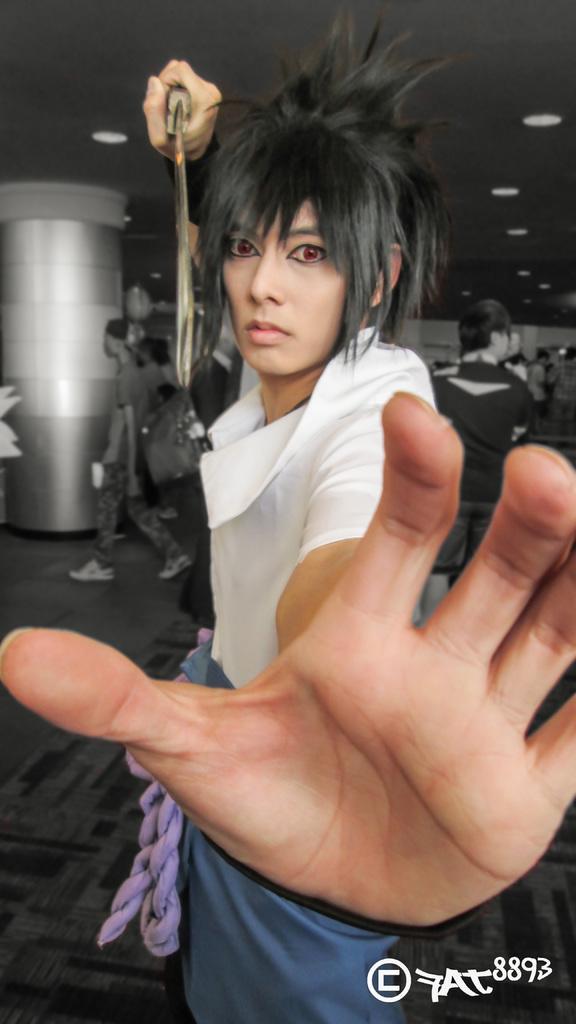In one or two sentences, can you explain what this image depicts? In this edited image there is a woman standing. She is holding a knife in her hand. The background is black and white in color. There are few people walking. To the left there is a pillar. There are lights to the ceiling. There is a carpet on the floor. In the bottom right there is text on the image. 